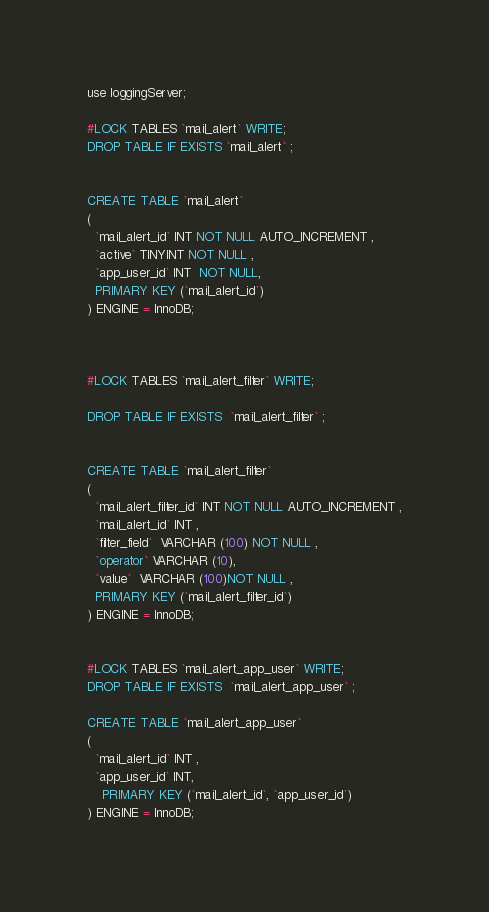Convert code to text. <code><loc_0><loc_0><loc_500><loc_500><_SQL_>

use loggingServer;

#LOCK TABLES `mail_alert` WRITE;
DROP TABLE IF EXISTS `mail_alert` ;


CREATE TABLE `mail_alert`
(
  `mail_alert_id` INT NOT NULL AUTO_INCREMENT ,
  `active` TINYINT NOT NULL ,
  `app_user_id` INT  NOT NULL,
  PRIMARY KEY (`mail_alert_id`)
) ENGINE = InnoDB;



#LOCK TABLES `mail_alert_filter` WRITE;

DROP TABLE IF EXISTS  `mail_alert_filter` ;


CREATE TABLE `mail_alert_filter`
(
  `mail_alert_filter_id` INT NOT NULL AUTO_INCREMENT ,
  `mail_alert_id` INT ,
  `filter_field`  VARCHAR (100) NOT NULL ,
  `operator` VARCHAR (10),
  `value`  VARCHAR (100)NOT NULL ,
  PRIMARY KEY (`mail_alert_filter_id`)
) ENGINE = InnoDB;


#LOCK TABLES `mail_alert_app_user` WRITE;
DROP TABLE IF EXISTS  `mail_alert_app_user` ;

CREATE TABLE `mail_alert_app_user`
(
  `mail_alert_id` INT ,
  `app_user_id` INT,
    PRIMARY KEY (`mail_alert_id`, `app_user_id`)
) ENGINE = InnoDB;

</code> 